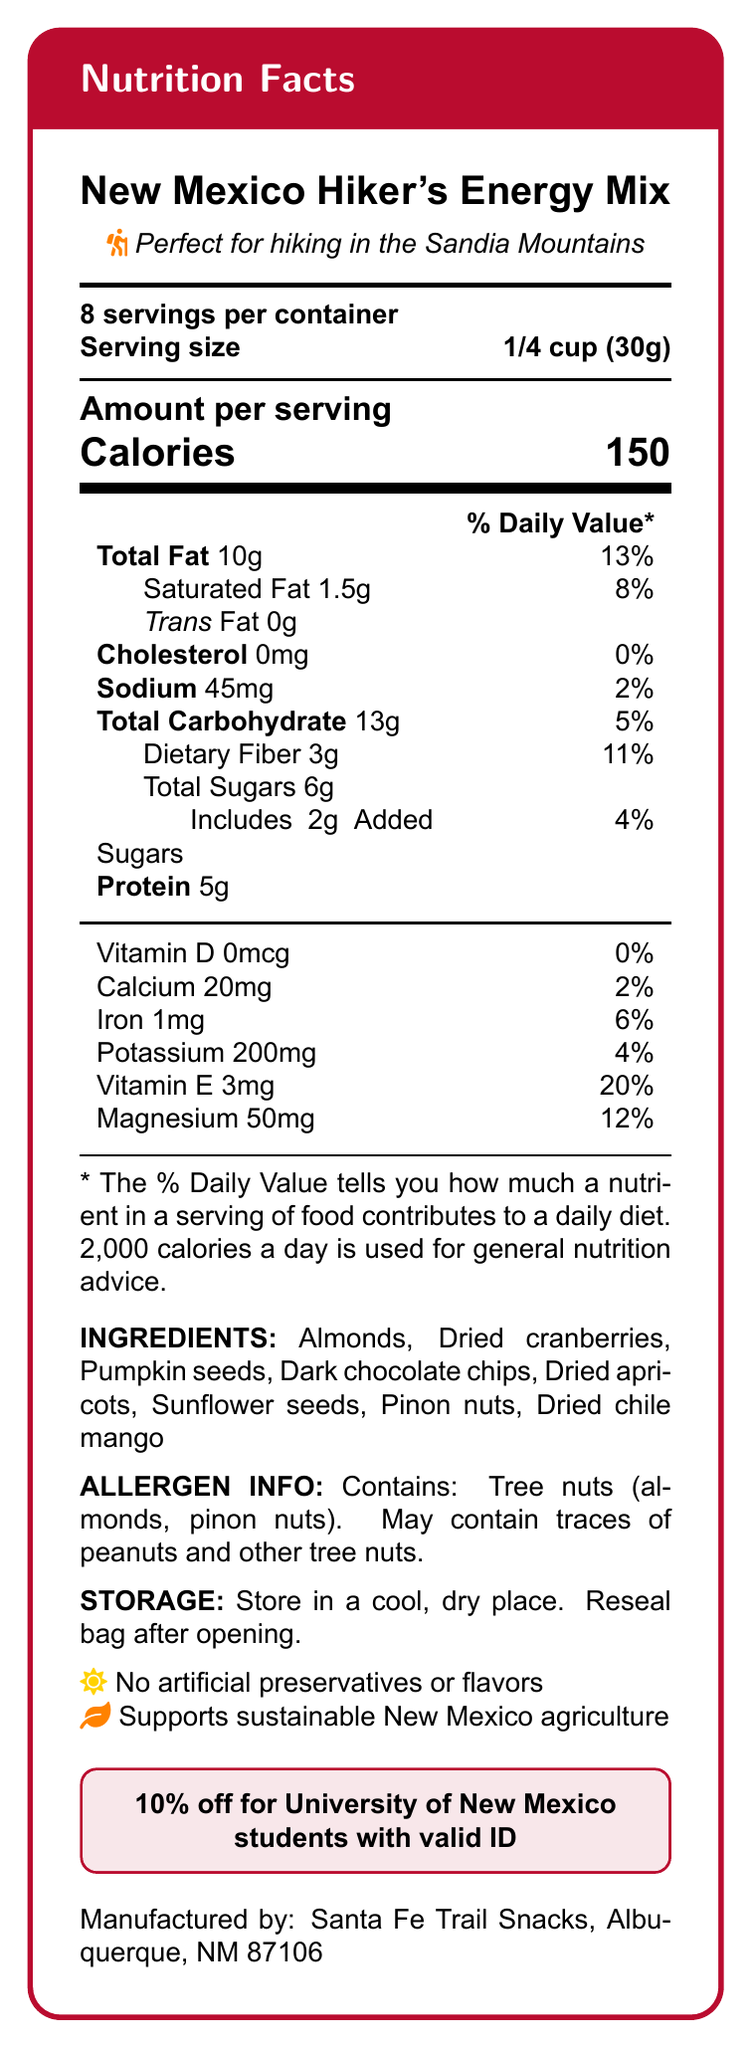How many servings are in the container? The document states that there are "8 servings per container."
Answer: 8 What is the serving size? The document specifies that the serving size is "1/4 cup (30g)."
Answer: 1/4 cup (30g) What is the total fat content per serving? The table under "Amount per serving" lists "Total Fat 10g."
Answer: 10g How much protein does each serving contain? The "Amount per serving" section lists "Protein 5g."
Answer: 5g What ingredients are included in the trail mix? The document lists all the ingredients under "INGREDIENTS."
Answer: Almonds, Dried cranberries, Pumpkin seeds, Dark chocolate chips, Dried apricots, Sunflower seeds, Pinon nuts, Dried chile mango How many calories are in one serving? The document states that each serving has "Calories 150."
Answer: 150 Which of the following vitamins and minerals are present in the mix? A. Vitamin A B. Vitamin D C. Vitamin E D. Calcium Vitamin E and Calcium are specified in the document, but Vitamin A is not listed, and Vitamin D is listed as 0%.
Answer: C and D How much added sugar does one serving contain? A. 1g B. 2g C. 3g D. 6g The "Amount per serving" section states "Includes 2g Added Sugars."
Answer: B Is there any trans fat in the trail mix? Yes/No The document lists "Trans Fat 0g," indicating there is no trans fat.
Answer: No What additional discount is available for University of New Mexico students? The document states "10% off for University of New Mexico students with valid ID."
Answer: 10% off Describe the entire document. The explanation covers the various sections of the document and summarizes the main ideas, including nutritional information, ingredients, allergen info, storage guidance, and promotional details.
Answer: The document is a nutrition label for "New Mexico Hiker's Energy Mix," providing details on serving size, servings per container, calorie content, and nutrient values per serving. It lists ingredients, allergen information, storage instructions, and promotional discounts for University of New Mexico students. The label emphasizes the mix is suitable for hiking, contains no artificial preservatives, and supports local agriculture. How much sodium is in one serving? The document lists "Sodium 45mg" in the "Amount per serving" section.
Answer: 45mg What is the total carbohydrate content per serving? The "Total Carbohydrate" content is listed as 13g in the document.
Answer: 13g Can the trail mix be stored at room temperature? The "STORAGE" section advises storing in a cool, dry place, which typically means room temperature is acceptable.
Answer: Yes Can this trail mix be eaten by someone with a peanut allergy without concern? The allergen information states it contains tree nuts and "May contain traces of peanuts," so it might not be safe for someone with a peanut allergy. However, it is not certain if it contains peanuts directly.
Answer: Not enough information 